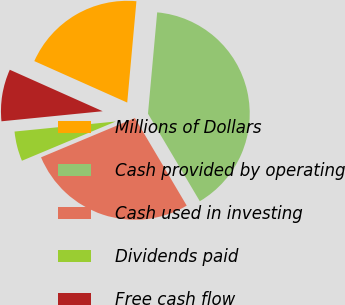Convert chart. <chart><loc_0><loc_0><loc_500><loc_500><pie_chart><fcel>Millions of Dollars<fcel>Cash provided by operating<fcel>Cash used in investing<fcel>Dividends paid<fcel>Free cash flow<nl><fcel>19.76%<fcel>40.05%<fcel>27.2%<fcel>4.73%<fcel>8.26%<nl></chart> 